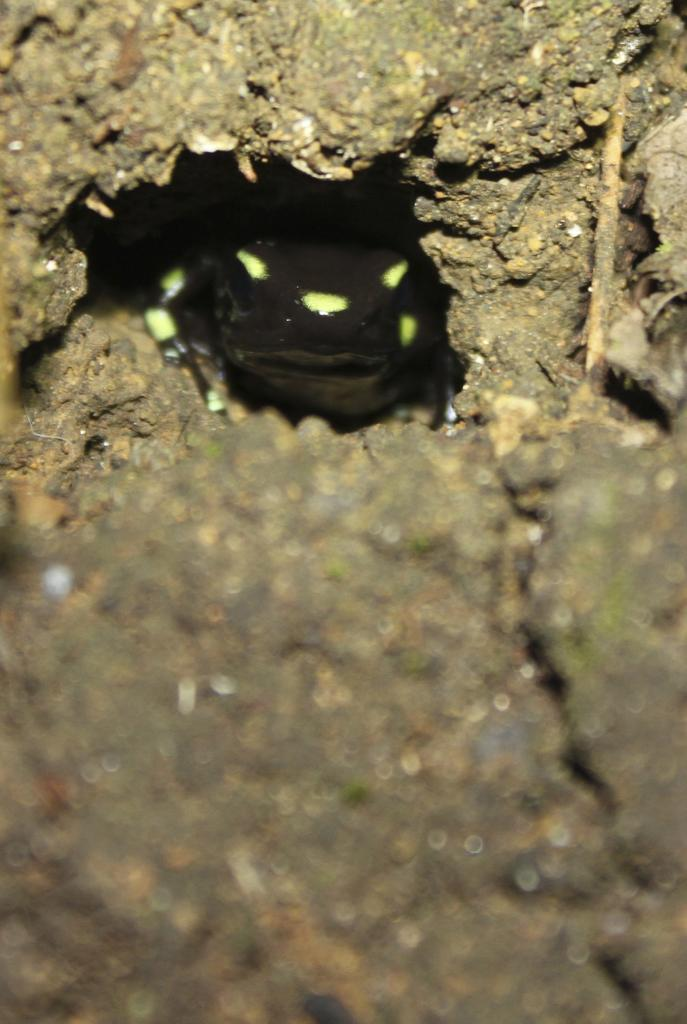What animal can be seen in the image? There is a frog in the image. What is the frog doing in the image? The frog is coming out from the sand. What type of pain is the frog experiencing in the image? There is no indication in the image that the frog is experiencing any pain. 